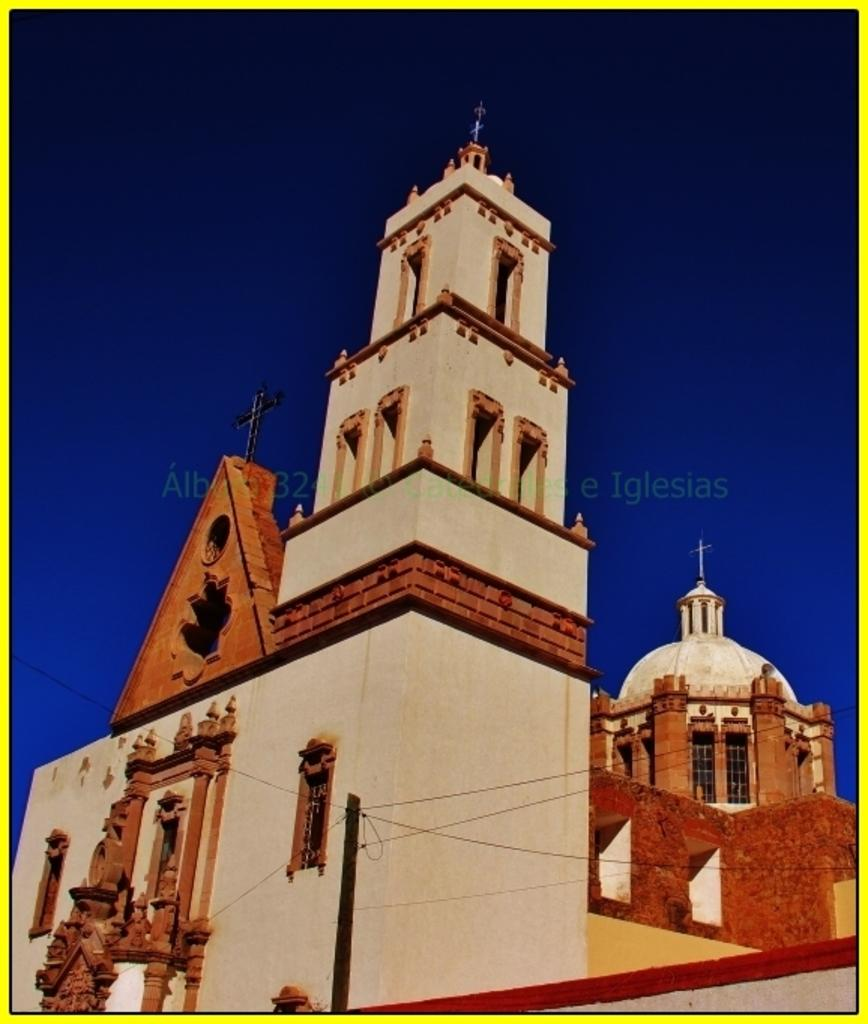What type of building is shown in the image? The image depicts a church. What architectural features can be seen on the church? The church has windows and arches. Are there any religious symbols on the church? Yes, there are crosses on the church. What can be seen in the background of the image? The sky is visible in the background of the image. How many selections of wealth are available in the image? There is no mention of wealth or selections in the image; it depicts a church with architectural features and religious symbols. Is there a bomb visible in the image? No, there is no bomb present in the image. 